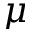Convert formula to latex. <formula><loc_0><loc_0><loc_500><loc_500>\mu</formula> 